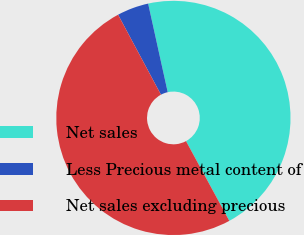Convert chart to OTSL. <chart><loc_0><loc_0><loc_500><loc_500><pie_chart><fcel>Net sales<fcel>Less Precious metal content of<fcel>Net sales excluding precious<nl><fcel>45.54%<fcel>4.37%<fcel>50.09%<nl></chart> 